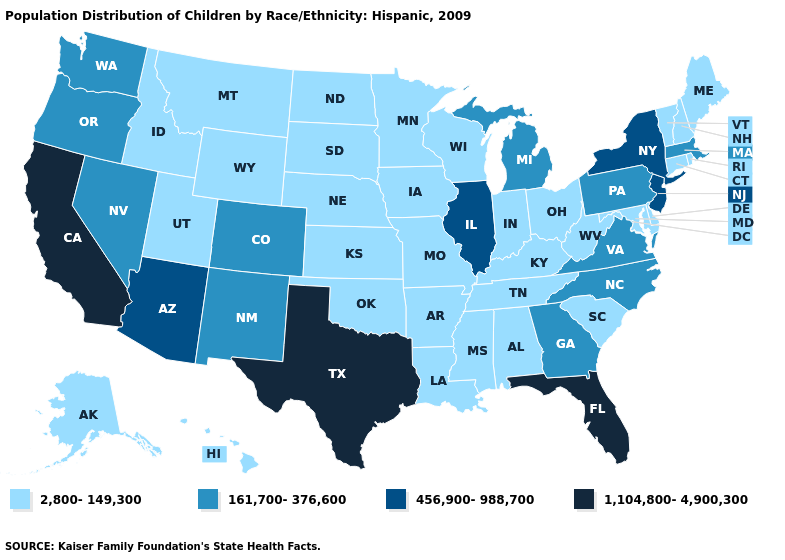What is the value of Florida?
Be succinct. 1,104,800-4,900,300. Name the states that have a value in the range 2,800-149,300?
Answer briefly. Alabama, Alaska, Arkansas, Connecticut, Delaware, Hawaii, Idaho, Indiana, Iowa, Kansas, Kentucky, Louisiana, Maine, Maryland, Minnesota, Mississippi, Missouri, Montana, Nebraska, New Hampshire, North Dakota, Ohio, Oklahoma, Rhode Island, South Carolina, South Dakota, Tennessee, Utah, Vermont, West Virginia, Wisconsin, Wyoming. Name the states that have a value in the range 456,900-988,700?
Be succinct. Arizona, Illinois, New Jersey, New York. Name the states that have a value in the range 1,104,800-4,900,300?
Quick response, please. California, Florida, Texas. Does the first symbol in the legend represent the smallest category?
Quick response, please. Yes. What is the value of West Virginia?
Short answer required. 2,800-149,300. Name the states that have a value in the range 1,104,800-4,900,300?
Short answer required. California, Florida, Texas. Does South Dakota have the same value as North Dakota?
Write a very short answer. Yes. Which states have the highest value in the USA?
Be succinct. California, Florida, Texas. What is the value of New Jersey?
Give a very brief answer. 456,900-988,700. What is the value of New York?
Quick response, please. 456,900-988,700. Name the states that have a value in the range 161,700-376,600?
Give a very brief answer. Colorado, Georgia, Massachusetts, Michigan, Nevada, New Mexico, North Carolina, Oregon, Pennsylvania, Virginia, Washington. What is the value of Louisiana?
Be succinct. 2,800-149,300. Among the states that border New Hampshire , does Massachusetts have the lowest value?
Be succinct. No. What is the value of Maine?
Write a very short answer. 2,800-149,300. 